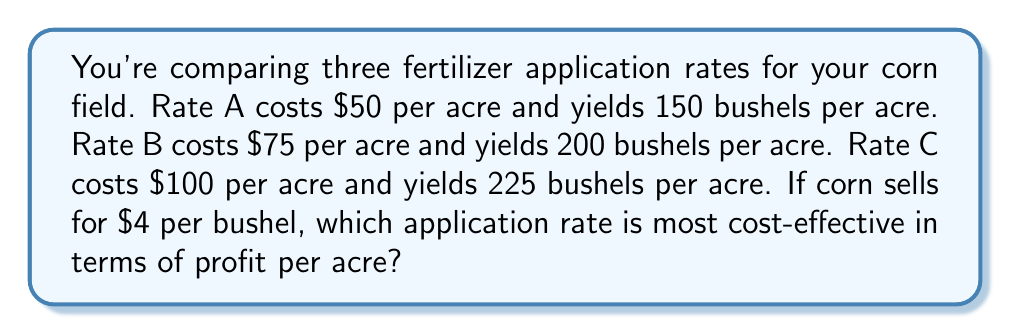Solve this math problem. Let's calculate the profit per acre for each application rate:

1. Rate A:
   Revenue: $150 \text{ bushels} \times \$4/\text{bushel} = \$600$
   Cost: $\$50$
   Profit: $\$600 - \$50 = \$550$ per acre

2. Rate B:
   Revenue: $200 \text{ bushels} \times \$4/\text{bushel} = \$800$
   Cost: $\$75$
   Profit: $\$800 - \$75 = \$725$ per acre

3. Rate C:
   Revenue: $225 \text{ bushels} \times \$4/\text{bushel} = \$900$
   Cost: $\$100$
   Profit: $\$900 - \$100 = \$800$ per acre

Comparing the profits:
Rate A: $\$550$ per acre
Rate B: $\$725$ per acre
Rate C: $\$800$ per acre

Rate C provides the highest profit per acre, making it the most cost-effective option.
Answer: Rate C 